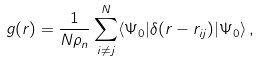<formula> <loc_0><loc_0><loc_500><loc_500>g ( { r } ) = \frac { 1 } { N \rho _ { n } } \sum _ { i \neq j } ^ { N } \langle \Psi _ { 0 } | \delta ( { r } - { r } _ { i j } ) | \Psi _ { 0 } \rangle \, ,</formula> 